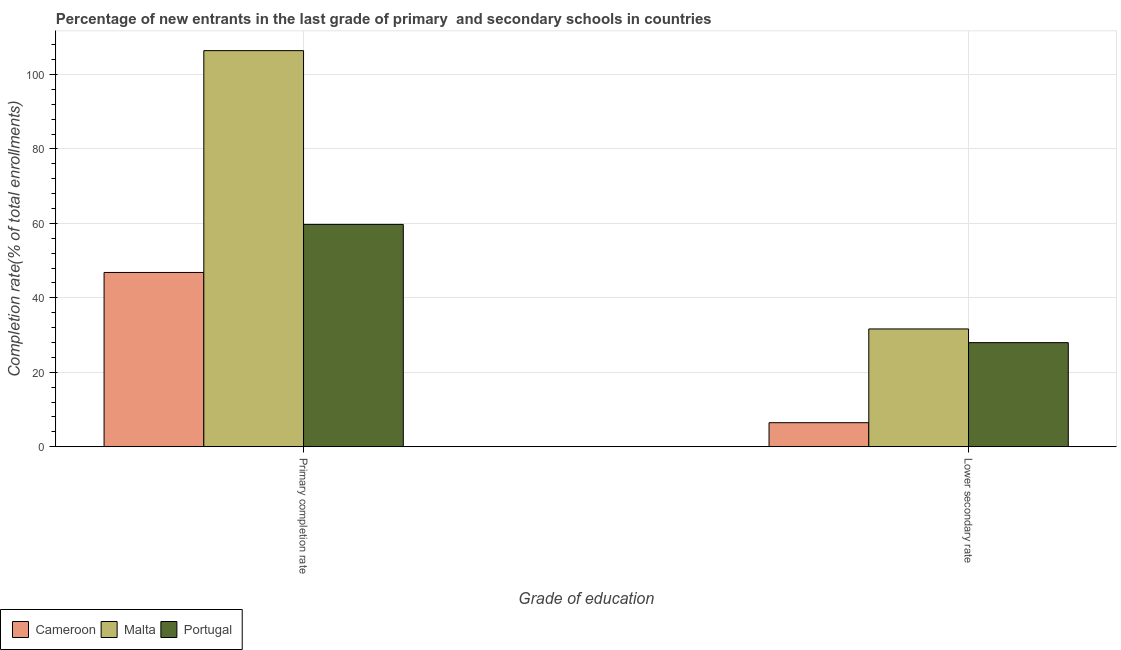Are the number of bars per tick equal to the number of legend labels?
Offer a terse response. Yes. Are the number of bars on each tick of the X-axis equal?
Offer a very short reply. Yes. What is the label of the 1st group of bars from the left?
Make the answer very short. Primary completion rate. What is the completion rate in secondary schools in Malta?
Offer a very short reply. 31.65. Across all countries, what is the maximum completion rate in secondary schools?
Make the answer very short. 31.65. Across all countries, what is the minimum completion rate in secondary schools?
Your response must be concise. 6.46. In which country was the completion rate in secondary schools maximum?
Provide a short and direct response. Malta. In which country was the completion rate in secondary schools minimum?
Your response must be concise. Cameroon. What is the total completion rate in secondary schools in the graph?
Your response must be concise. 66.07. What is the difference between the completion rate in primary schools in Cameroon and that in Malta?
Give a very brief answer. -59.6. What is the difference between the completion rate in secondary schools in Portugal and the completion rate in primary schools in Cameroon?
Your answer should be compact. -18.86. What is the average completion rate in primary schools per country?
Your answer should be compact. 71. What is the difference between the completion rate in secondary schools and completion rate in primary schools in Malta?
Offer a very short reply. -74.78. What is the ratio of the completion rate in primary schools in Cameroon to that in Malta?
Provide a short and direct response. 0.44. What does the 2nd bar from the right in Lower secondary rate represents?
Offer a terse response. Malta. How many bars are there?
Provide a succinct answer. 6. Are all the bars in the graph horizontal?
Your answer should be compact. No. Does the graph contain any zero values?
Give a very brief answer. No. Where does the legend appear in the graph?
Your answer should be compact. Bottom left. How many legend labels are there?
Your answer should be very brief. 3. How are the legend labels stacked?
Your answer should be compact. Horizontal. What is the title of the graph?
Your answer should be compact. Percentage of new entrants in the last grade of primary  and secondary schools in countries. What is the label or title of the X-axis?
Provide a short and direct response. Grade of education. What is the label or title of the Y-axis?
Your answer should be very brief. Completion rate(% of total enrollments). What is the Completion rate(% of total enrollments) in Cameroon in Primary completion rate?
Give a very brief answer. 46.83. What is the Completion rate(% of total enrollments) in Malta in Primary completion rate?
Make the answer very short. 106.43. What is the Completion rate(% of total enrollments) in Portugal in Primary completion rate?
Provide a short and direct response. 59.74. What is the Completion rate(% of total enrollments) of Cameroon in Lower secondary rate?
Make the answer very short. 6.46. What is the Completion rate(% of total enrollments) in Malta in Lower secondary rate?
Provide a short and direct response. 31.65. What is the Completion rate(% of total enrollments) in Portugal in Lower secondary rate?
Ensure brevity in your answer.  27.97. Across all Grade of education, what is the maximum Completion rate(% of total enrollments) of Cameroon?
Give a very brief answer. 46.83. Across all Grade of education, what is the maximum Completion rate(% of total enrollments) in Malta?
Make the answer very short. 106.43. Across all Grade of education, what is the maximum Completion rate(% of total enrollments) in Portugal?
Your response must be concise. 59.74. Across all Grade of education, what is the minimum Completion rate(% of total enrollments) of Cameroon?
Make the answer very short. 6.46. Across all Grade of education, what is the minimum Completion rate(% of total enrollments) in Malta?
Ensure brevity in your answer.  31.65. Across all Grade of education, what is the minimum Completion rate(% of total enrollments) of Portugal?
Ensure brevity in your answer.  27.97. What is the total Completion rate(% of total enrollments) in Cameroon in the graph?
Provide a short and direct response. 53.28. What is the total Completion rate(% of total enrollments) of Malta in the graph?
Offer a terse response. 138.08. What is the total Completion rate(% of total enrollments) in Portugal in the graph?
Your answer should be compact. 87.71. What is the difference between the Completion rate(% of total enrollments) of Cameroon in Primary completion rate and that in Lower secondary rate?
Ensure brevity in your answer.  40.37. What is the difference between the Completion rate(% of total enrollments) of Malta in Primary completion rate and that in Lower secondary rate?
Your response must be concise. 74.78. What is the difference between the Completion rate(% of total enrollments) of Portugal in Primary completion rate and that in Lower secondary rate?
Your answer should be very brief. 31.77. What is the difference between the Completion rate(% of total enrollments) of Cameroon in Primary completion rate and the Completion rate(% of total enrollments) of Malta in Lower secondary rate?
Ensure brevity in your answer.  15.18. What is the difference between the Completion rate(% of total enrollments) of Cameroon in Primary completion rate and the Completion rate(% of total enrollments) of Portugal in Lower secondary rate?
Offer a very short reply. 18.86. What is the difference between the Completion rate(% of total enrollments) in Malta in Primary completion rate and the Completion rate(% of total enrollments) in Portugal in Lower secondary rate?
Offer a terse response. 78.46. What is the average Completion rate(% of total enrollments) in Cameroon per Grade of education?
Provide a succinct answer. 26.64. What is the average Completion rate(% of total enrollments) of Malta per Grade of education?
Make the answer very short. 69.04. What is the average Completion rate(% of total enrollments) of Portugal per Grade of education?
Offer a terse response. 43.85. What is the difference between the Completion rate(% of total enrollments) of Cameroon and Completion rate(% of total enrollments) of Malta in Primary completion rate?
Keep it short and to the point. -59.6. What is the difference between the Completion rate(% of total enrollments) in Cameroon and Completion rate(% of total enrollments) in Portugal in Primary completion rate?
Provide a short and direct response. -12.91. What is the difference between the Completion rate(% of total enrollments) of Malta and Completion rate(% of total enrollments) of Portugal in Primary completion rate?
Give a very brief answer. 46.69. What is the difference between the Completion rate(% of total enrollments) of Cameroon and Completion rate(% of total enrollments) of Malta in Lower secondary rate?
Give a very brief answer. -25.19. What is the difference between the Completion rate(% of total enrollments) of Cameroon and Completion rate(% of total enrollments) of Portugal in Lower secondary rate?
Give a very brief answer. -21.51. What is the difference between the Completion rate(% of total enrollments) of Malta and Completion rate(% of total enrollments) of Portugal in Lower secondary rate?
Your answer should be compact. 3.68. What is the ratio of the Completion rate(% of total enrollments) of Cameroon in Primary completion rate to that in Lower secondary rate?
Keep it short and to the point. 7.25. What is the ratio of the Completion rate(% of total enrollments) in Malta in Primary completion rate to that in Lower secondary rate?
Keep it short and to the point. 3.36. What is the ratio of the Completion rate(% of total enrollments) of Portugal in Primary completion rate to that in Lower secondary rate?
Offer a very short reply. 2.14. What is the difference between the highest and the second highest Completion rate(% of total enrollments) of Cameroon?
Provide a short and direct response. 40.37. What is the difference between the highest and the second highest Completion rate(% of total enrollments) in Malta?
Your response must be concise. 74.78. What is the difference between the highest and the second highest Completion rate(% of total enrollments) in Portugal?
Your answer should be very brief. 31.77. What is the difference between the highest and the lowest Completion rate(% of total enrollments) of Cameroon?
Provide a short and direct response. 40.37. What is the difference between the highest and the lowest Completion rate(% of total enrollments) in Malta?
Offer a very short reply. 74.78. What is the difference between the highest and the lowest Completion rate(% of total enrollments) of Portugal?
Keep it short and to the point. 31.77. 